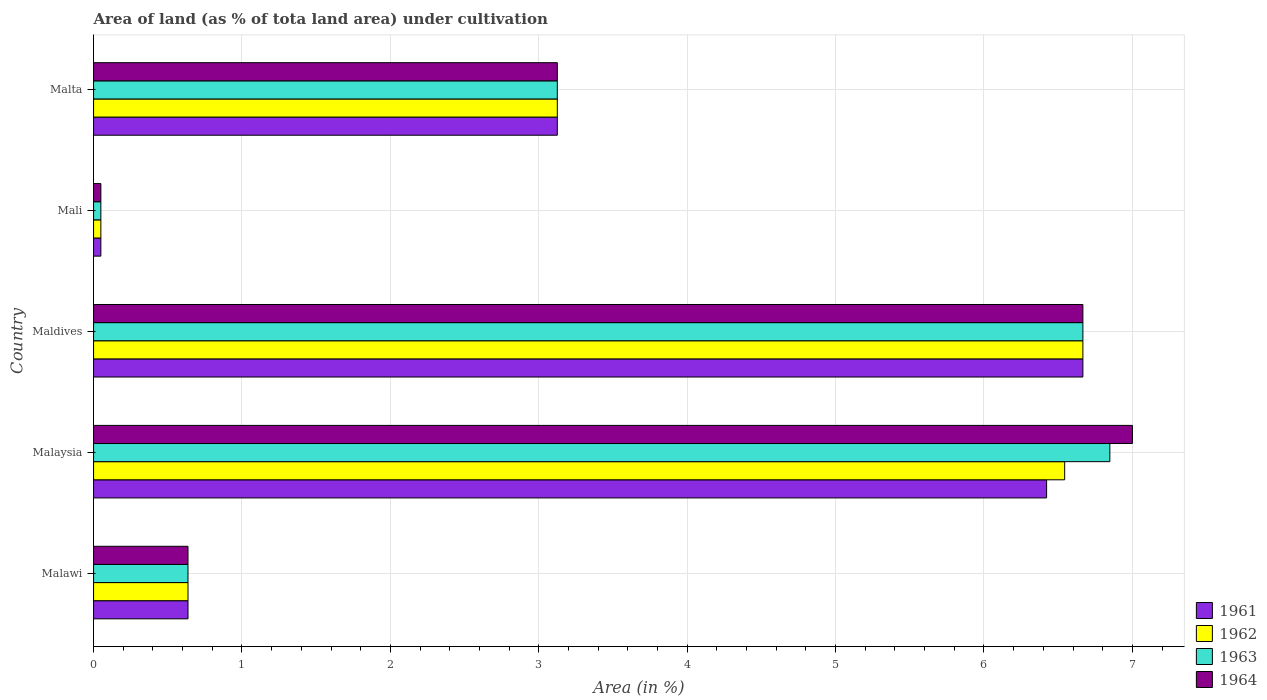How many different coloured bars are there?
Make the answer very short. 4. Are the number of bars on each tick of the Y-axis equal?
Your response must be concise. Yes. What is the label of the 1st group of bars from the top?
Your answer should be compact. Malta. What is the percentage of land under cultivation in 1964 in Malaysia?
Your answer should be very brief. 7. Across all countries, what is the maximum percentage of land under cultivation in 1964?
Give a very brief answer. 7. Across all countries, what is the minimum percentage of land under cultivation in 1963?
Provide a short and direct response. 0.05. In which country was the percentage of land under cultivation in 1962 maximum?
Make the answer very short. Maldives. In which country was the percentage of land under cultivation in 1963 minimum?
Your response must be concise. Mali. What is the total percentage of land under cultivation in 1963 in the graph?
Give a very brief answer. 17.33. What is the difference between the percentage of land under cultivation in 1961 in Mali and that in Malta?
Ensure brevity in your answer.  -3.08. What is the difference between the percentage of land under cultivation in 1961 in Maldives and the percentage of land under cultivation in 1962 in Malawi?
Ensure brevity in your answer.  6.03. What is the average percentage of land under cultivation in 1963 per country?
Your answer should be compact. 3.47. What is the difference between the percentage of land under cultivation in 1964 and percentage of land under cultivation in 1962 in Mali?
Offer a very short reply. 0. What is the ratio of the percentage of land under cultivation in 1963 in Malaysia to that in Maldives?
Keep it short and to the point. 1.03. Is the percentage of land under cultivation in 1961 in Maldives less than that in Malta?
Provide a short and direct response. No. Is the difference between the percentage of land under cultivation in 1964 in Mali and Malta greater than the difference between the percentage of land under cultivation in 1962 in Mali and Malta?
Ensure brevity in your answer.  No. What is the difference between the highest and the second highest percentage of land under cultivation in 1962?
Provide a succinct answer. 0.12. What is the difference between the highest and the lowest percentage of land under cultivation in 1961?
Offer a terse response. 6.62. Is the sum of the percentage of land under cultivation in 1964 in Malawi and Malaysia greater than the maximum percentage of land under cultivation in 1963 across all countries?
Your response must be concise. Yes. Is it the case that in every country, the sum of the percentage of land under cultivation in 1963 and percentage of land under cultivation in 1962 is greater than the sum of percentage of land under cultivation in 1964 and percentage of land under cultivation in 1961?
Provide a short and direct response. No. Is it the case that in every country, the sum of the percentage of land under cultivation in 1964 and percentage of land under cultivation in 1963 is greater than the percentage of land under cultivation in 1962?
Provide a succinct answer. Yes. What is the difference between two consecutive major ticks on the X-axis?
Your answer should be compact. 1. Does the graph contain grids?
Your response must be concise. Yes. Where does the legend appear in the graph?
Offer a very short reply. Bottom right. How many legend labels are there?
Provide a short and direct response. 4. What is the title of the graph?
Provide a short and direct response. Area of land (as % of tota land area) under cultivation. What is the label or title of the X-axis?
Your answer should be very brief. Area (in %). What is the label or title of the Y-axis?
Your answer should be compact. Country. What is the Area (in %) in 1961 in Malawi?
Your answer should be compact. 0.64. What is the Area (in %) in 1962 in Malawi?
Your answer should be very brief. 0.64. What is the Area (in %) of 1963 in Malawi?
Offer a very short reply. 0.64. What is the Area (in %) of 1964 in Malawi?
Ensure brevity in your answer.  0.64. What is the Area (in %) of 1961 in Malaysia?
Keep it short and to the point. 6.42. What is the Area (in %) of 1962 in Malaysia?
Provide a short and direct response. 6.54. What is the Area (in %) in 1963 in Malaysia?
Offer a very short reply. 6.85. What is the Area (in %) of 1964 in Malaysia?
Ensure brevity in your answer.  7. What is the Area (in %) of 1961 in Maldives?
Provide a succinct answer. 6.67. What is the Area (in %) of 1962 in Maldives?
Your response must be concise. 6.67. What is the Area (in %) of 1963 in Maldives?
Provide a succinct answer. 6.67. What is the Area (in %) in 1964 in Maldives?
Offer a terse response. 6.67. What is the Area (in %) in 1961 in Mali?
Offer a very short reply. 0.05. What is the Area (in %) in 1962 in Mali?
Provide a succinct answer. 0.05. What is the Area (in %) in 1963 in Mali?
Ensure brevity in your answer.  0.05. What is the Area (in %) in 1964 in Mali?
Make the answer very short. 0.05. What is the Area (in %) in 1961 in Malta?
Your answer should be compact. 3.12. What is the Area (in %) in 1962 in Malta?
Provide a succinct answer. 3.12. What is the Area (in %) of 1963 in Malta?
Offer a very short reply. 3.12. What is the Area (in %) in 1964 in Malta?
Your response must be concise. 3.12. Across all countries, what is the maximum Area (in %) in 1961?
Make the answer very short. 6.67. Across all countries, what is the maximum Area (in %) in 1962?
Make the answer very short. 6.67. Across all countries, what is the maximum Area (in %) of 1963?
Give a very brief answer. 6.85. Across all countries, what is the maximum Area (in %) of 1964?
Give a very brief answer. 7. Across all countries, what is the minimum Area (in %) in 1961?
Offer a terse response. 0.05. Across all countries, what is the minimum Area (in %) of 1962?
Ensure brevity in your answer.  0.05. Across all countries, what is the minimum Area (in %) of 1963?
Your answer should be very brief. 0.05. Across all countries, what is the minimum Area (in %) in 1964?
Provide a succinct answer. 0.05. What is the total Area (in %) of 1961 in the graph?
Provide a short and direct response. 16.9. What is the total Area (in %) of 1962 in the graph?
Provide a succinct answer. 17.02. What is the total Area (in %) of 1963 in the graph?
Keep it short and to the point. 17.33. What is the total Area (in %) of 1964 in the graph?
Keep it short and to the point. 17.48. What is the difference between the Area (in %) of 1961 in Malawi and that in Malaysia?
Ensure brevity in your answer.  -5.79. What is the difference between the Area (in %) in 1962 in Malawi and that in Malaysia?
Your response must be concise. -5.91. What is the difference between the Area (in %) in 1963 in Malawi and that in Malaysia?
Keep it short and to the point. -6.21. What is the difference between the Area (in %) of 1964 in Malawi and that in Malaysia?
Your response must be concise. -6.36. What is the difference between the Area (in %) in 1961 in Malawi and that in Maldives?
Provide a succinct answer. -6.03. What is the difference between the Area (in %) of 1962 in Malawi and that in Maldives?
Offer a very short reply. -6.03. What is the difference between the Area (in %) in 1963 in Malawi and that in Maldives?
Offer a terse response. -6.03. What is the difference between the Area (in %) of 1964 in Malawi and that in Maldives?
Offer a terse response. -6.03. What is the difference between the Area (in %) in 1961 in Malawi and that in Mali?
Give a very brief answer. 0.59. What is the difference between the Area (in %) of 1962 in Malawi and that in Mali?
Provide a succinct answer. 0.59. What is the difference between the Area (in %) in 1963 in Malawi and that in Mali?
Offer a very short reply. 0.59. What is the difference between the Area (in %) of 1964 in Malawi and that in Mali?
Make the answer very short. 0.59. What is the difference between the Area (in %) of 1961 in Malawi and that in Malta?
Make the answer very short. -2.49. What is the difference between the Area (in %) of 1962 in Malawi and that in Malta?
Provide a succinct answer. -2.49. What is the difference between the Area (in %) in 1963 in Malawi and that in Malta?
Give a very brief answer. -2.49. What is the difference between the Area (in %) in 1964 in Malawi and that in Malta?
Your answer should be compact. -2.49. What is the difference between the Area (in %) of 1961 in Malaysia and that in Maldives?
Provide a succinct answer. -0.24. What is the difference between the Area (in %) in 1962 in Malaysia and that in Maldives?
Give a very brief answer. -0.12. What is the difference between the Area (in %) of 1963 in Malaysia and that in Maldives?
Make the answer very short. 0.18. What is the difference between the Area (in %) in 1964 in Malaysia and that in Maldives?
Provide a succinct answer. 0.33. What is the difference between the Area (in %) in 1961 in Malaysia and that in Mali?
Your response must be concise. 6.37. What is the difference between the Area (in %) in 1962 in Malaysia and that in Mali?
Your response must be concise. 6.49. What is the difference between the Area (in %) of 1963 in Malaysia and that in Mali?
Offer a very short reply. 6.8. What is the difference between the Area (in %) in 1964 in Malaysia and that in Mali?
Offer a very short reply. 6.95. What is the difference between the Area (in %) of 1961 in Malaysia and that in Malta?
Offer a very short reply. 3.3. What is the difference between the Area (in %) in 1962 in Malaysia and that in Malta?
Keep it short and to the point. 3.42. What is the difference between the Area (in %) of 1963 in Malaysia and that in Malta?
Give a very brief answer. 3.72. What is the difference between the Area (in %) of 1964 in Malaysia and that in Malta?
Make the answer very short. 3.88. What is the difference between the Area (in %) of 1961 in Maldives and that in Mali?
Ensure brevity in your answer.  6.62. What is the difference between the Area (in %) in 1962 in Maldives and that in Mali?
Your response must be concise. 6.62. What is the difference between the Area (in %) in 1963 in Maldives and that in Mali?
Give a very brief answer. 6.62. What is the difference between the Area (in %) of 1964 in Maldives and that in Mali?
Ensure brevity in your answer.  6.62. What is the difference between the Area (in %) of 1961 in Maldives and that in Malta?
Your answer should be compact. 3.54. What is the difference between the Area (in %) in 1962 in Maldives and that in Malta?
Offer a terse response. 3.54. What is the difference between the Area (in %) of 1963 in Maldives and that in Malta?
Your response must be concise. 3.54. What is the difference between the Area (in %) in 1964 in Maldives and that in Malta?
Keep it short and to the point. 3.54. What is the difference between the Area (in %) of 1961 in Mali and that in Malta?
Provide a short and direct response. -3.08. What is the difference between the Area (in %) of 1962 in Mali and that in Malta?
Offer a terse response. -3.08. What is the difference between the Area (in %) of 1963 in Mali and that in Malta?
Keep it short and to the point. -3.08. What is the difference between the Area (in %) in 1964 in Mali and that in Malta?
Keep it short and to the point. -3.08. What is the difference between the Area (in %) in 1961 in Malawi and the Area (in %) in 1962 in Malaysia?
Give a very brief answer. -5.91. What is the difference between the Area (in %) in 1961 in Malawi and the Area (in %) in 1963 in Malaysia?
Make the answer very short. -6.21. What is the difference between the Area (in %) in 1961 in Malawi and the Area (in %) in 1964 in Malaysia?
Offer a very short reply. -6.36. What is the difference between the Area (in %) of 1962 in Malawi and the Area (in %) of 1963 in Malaysia?
Ensure brevity in your answer.  -6.21. What is the difference between the Area (in %) of 1962 in Malawi and the Area (in %) of 1964 in Malaysia?
Ensure brevity in your answer.  -6.36. What is the difference between the Area (in %) in 1963 in Malawi and the Area (in %) in 1964 in Malaysia?
Keep it short and to the point. -6.36. What is the difference between the Area (in %) in 1961 in Malawi and the Area (in %) in 1962 in Maldives?
Provide a short and direct response. -6.03. What is the difference between the Area (in %) of 1961 in Malawi and the Area (in %) of 1963 in Maldives?
Provide a short and direct response. -6.03. What is the difference between the Area (in %) of 1961 in Malawi and the Area (in %) of 1964 in Maldives?
Make the answer very short. -6.03. What is the difference between the Area (in %) in 1962 in Malawi and the Area (in %) in 1963 in Maldives?
Give a very brief answer. -6.03. What is the difference between the Area (in %) of 1962 in Malawi and the Area (in %) of 1964 in Maldives?
Keep it short and to the point. -6.03. What is the difference between the Area (in %) of 1963 in Malawi and the Area (in %) of 1964 in Maldives?
Make the answer very short. -6.03. What is the difference between the Area (in %) in 1961 in Malawi and the Area (in %) in 1962 in Mali?
Your response must be concise. 0.59. What is the difference between the Area (in %) in 1961 in Malawi and the Area (in %) in 1963 in Mali?
Offer a very short reply. 0.59. What is the difference between the Area (in %) in 1961 in Malawi and the Area (in %) in 1964 in Mali?
Offer a terse response. 0.59. What is the difference between the Area (in %) in 1962 in Malawi and the Area (in %) in 1963 in Mali?
Offer a terse response. 0.59. What is the difference between the Area (in %) in 1962 in Malawi and the Area (in %) in 1964 in Mali?
Provide a succinct answer. 0.59. What is the difference between the Area (in %) of 1963 in Malawi and the Area (in %) of 1964 in Mali?
Provide a succinct answer. 0.59. What is the difference between the Area (in %) in 1961 in Malawi and the Area (in %) in 1962 in Malta?
Offer a terse response. -2.49. What is the difference between the Area (in %) of 1961 in Malawi and the Area (in %) of 1963 in Malta?
Make the answer very short. -2.49. What is the difference between the Area (in %) in 1961 in Malawi and the Area (in %) in 1964 in Malta?
Ensure brevity in your answer.  -2.49. What is the difference between the Area (in %) in 1962 in Malawi and the Area (in %) in 1963 in Malta?
Make the answer very short. -2.49. What is the difference between the Area (in %) in 1962 in Malawi and the Area (in %) in 1964 in Malta?
Provide a succinct answer. -2.49. What is the difference between the Area (in %) in 1963 in Malawi and the Area (in %) in 1964 in Malta?
Offer a terse response. -2.49. What is the difference between the Area (in %) of 1961 in Malaysia and the Area (in %) of 1962 in Maldives?
Provide a short and direct response. -0.24. What is the difference between the Area (in %) of 1961 in Malaysia and the Area (in %) of 1963 in Maldives?
Your answer should be very brief. -0.24. What is the difference between the Area (in %) of 1961 in Malaysia and the Area (in %) of 1964 in Maldives?
Give a very brief answer. -0.24. What is the difference between the Area (in %) in 1962 in Malaysia and the Area (in %) in 1963 in Maldives?
Provide a short and direct response. -0.12. What is the difference between the Area (in %) of 1962 in Malaysia and the Area (in %) of 1964 in Maldives?
Your response must be concise. -0.12. What is the difference between the Area (in %) of 1963 in Malaysia and the Area (in %) of 1964 in Maldives?
Your answer should be compact. 0.18. What is the difference between the Area (in %) of 1961 in Malaysia and the Area (in %) of 1962 in Mali?
Make the answer very short. 6.37. What is the difference between the Area (in %) of 1961 in Malaysia and the Area (in %) of 1963 in Mali?
Keep it short and to the point. 6.37. What is the difference between the Area (in %) of 1961 in Malaysia and the Area (in %) of 1964 in Mali?
Make the answer very short. 6.37. What is the difference between the Area (in %) in 1962 in Malaysia and the Area (in %) in 1963 in Mali?
Ensure brevity in your answer.  6.49. What is the difference between the Area (in %) of 1962 in Malaysia and the Area (in %) of 1964 in Mali?
Provide a short and direct response. 6.49. What is the difference between the Area (in %) in 1963 in Malaysia and the Area (in %) in 1964 in Mali?
Keep it short and to the point. 6.8. What is the difference between the Area (in %) in 1961 in Malaysia and the Area (in %) in 1962 in Malta?
Keep it short and to the point. 3.3. What is the difference between the Area (in %) of 1961 in Malaysia and the Area (in %) of 1963 in Malta?
Give a very brief answer. 3.3. What is the difference between the Area (in %) in 1961 in Malaysia and the Area (in %) in 1964 in Malta?
Give a very brief answer. 3.3. What is the difference between the Area (in %) in 1962 in Malaysia and the Area (in %) in 1963 in Malta?
Your answer should be very brief. 3.42. What is the difference between the Area (in %) in 1962 in Malaysia and the Area (in %) in 1964 in Malta?
Offer a very short reply. 3.42. What is the difference between the Area (in %) of 1963 in Malaysia and the Area (in %) of 1964 in Malta?
Your answer should be compact. 3.72. What is the difference between the Area (in %) in 1961 in Maldives and the Area (in %) in 1962 in Mali?
Make the answer very short. 6.62. What is the difference between the Area (in %) in 1961 in Maldives and the Area (in %) in 1963 in Mali?
Your response must be concise. 6.62. What is the difference between the Area (in %) of 1961 in Maldives and the Area (in %) of 1964 in Mali?
Provide a short and direct response. 6.62. What is the difference between the Area (in %) in 1962 in Maldives and the Area (in %) in 1963 in Mali?
Ensure brevity in your answer.  6.62. What is the difference between the Area (in %) of 1962 in Maldives and the Area (in %) of 1964 in Mali?
Your answer should be compact. 6.62. What is the difference between the Area (in %) of 1963 in Maldives and the Area (in %) of 1964 in Mali?
Offer a very short reply. 6.62. What is the difference between the Area (in %) of 1961 in Maldives and the Area (in %) of 1962 in Malta?
Provide a succinct answer. 3.54. What is the difference between the Area (in %) in 1961 in Maldives and the Area (in %) in 1963 in Malta?
Provide a succinct answer. 3.54. What is the difference between the Area (in %) of 1961 in Maldives and the Area (in %) of 1964 in Malta?
Your response must be concise. 3.54. What is the difference between the Area (in %) in 1962 in Maldives and the Area (in %) in 1963 in Malta?
Make the answer very short. 3.54. What is the difference between the Area (in %) of 1962 in Maldives and the Area (in %) of 1964 in Malta?
Provide a short and direct response. 3.54. What is the difference between the Area (in %) in 1963 in Maldives and the Area (in %) in 1964 in Malta?
Provide a short and direct response. 3.54. What is the difference between the Area (in %) in 1961 in Mali and the Area (in %) in 1962 in Malta?
Ensure brevity in your answer.  -3.08. What is the difference between the Area (in %) in 1961 in Mali and the Area (in %) in 1963 in Malta?
Provide a succinct answer. -3.08. What is the difference between the Area (in %) of 1961 in Mali and the Area (in %) of 1964 in Malta?
Ensure brevity in your answer.  -3.08. What is the difference between the Area (in %) in 1962 in Mali and the Area (in %) in 1963 in Malta?
Give a very brief answer. -3.08. What is the difference between the Area (in %) of 1962 in Mali and the Area (in %) of 1964 in Malta?
Your answer should be very brief. -3.08. What is the difference between the Area (in %) in 1963 in Mali and the Area (in %) in 1964 in Malta?
Your response must be concise. -3.08. What is the average Area (in %) of 1961 per country?
Your response must be concise. 3.38. What is the average Area (in %) in 1962 per country?
Ensure brevity in your answer.  3.4. What is the average Area (in %) of 1963 per country?
Ensure brevity in your answer.  3.47. What is the average Area (in %) in 1964 per country?
Offer a terse response. 3.5. What is the difference between the Area (in %) of 1961 and Area (in %) of 1962 in Malawi?
Give a very brief answer. 0. What is the difference between the Area (in %) in 1961 and Area (in %) in 1963 in Malawi?
Your answer should be very brief. 0. What is the difference between the Area (in %) in 1961 and Area (in %) in 1964 in Malawi?
Offer a very short reply. 0. What is the difference between the Area (in %) of 1963 and Area (in %) of 1964 in Malawi?
Provide a succinct answer. 0. What is the difference between the Area (in %) in 1961 and Area (in %) in 1962 in Malaysia?
Provide a succinct answer. -0.12. What is the difference between the Area (in %) of 1961 and Area (in %) of 1963 in Malaysia?
Offer a terse response. -0.43. What is the difference between the Area (in %) in 1961 and Area (in %) in 1964 in Malaysia?
Make the answer very short. -0.58. What is the difference between the Area (in %) in 1962 and Area (in %) in 1963 in Malaysia?
Your answer should be compact. -0.3. What is the difference between the Area (in %) of 1962 and Area (in %) of 1964 in Malaysia?
Your response must be concise. -0.46. What is the difference between the Area (in %) in 1963 and Area (in %) in 1964 in Malaysia?
Offer a very short reply. -0.15. What is the difference between the Area (in %) of 1961 and Area (in %) of 1962 in Maldives?
Your response must be concise. 0. What is the difference between the Area (in %) in 1962 and Area (in %) in 1963 in Maldives?
Your answer should be very brief. 0. What is the difference between the Area (in %) of 1962 and Area (in %) of 1964 in Maldives?
Your answer should be compact. 0. What is the difference between the Area (in %) in 1961 and Area (in %) in 1963 in Mali?
Make the answer very short. 0. What is the difference between the Area (in %) in 1961 and Area (in %) in 1964 in Mali?
Your response must be concise. 0. What is the difference between the Area (in %) of 1962 and Area (in %) of 1963 in Mali?
Provide a short and direct response. 0. What is the difference between the Area (in %) of 1961 and Area (in %) of 1962 in Malta?
Your answer should be very brief. 0. What is the difference between the Area (in %) in 1961 and Area (in %) in 1964 in Malta?
Offer a very short reply. 0. What is the difference between the Area (in %) in 1962 and Area (in %) in 1964 in Malta?
Your response must be concise. 0. What is the ratio of the Area (in %) of 1961 in Malawi to that in Malaysia?
Ensure brevity in your answer.  0.1. What is the ratio of the Area (in %) in 1962 in Malawi to that in Malaysia?
Your answer should be very brief. 0.1. What is the ratio of the Area (in %) in 1963 in Malawi to that in Malaysia?
Your response must be concise. 0.09. What is the ratio of the Area (in %) in 1964 in Malawi to that in Malaysia?
Give a very brief answer. 0.09. What is the ratio of the Area (in %) of 1961 in Malawi to that in Maldives?
Provide a succinct answer. 0.1. What is the ratio of the Area (in %) of 1962 in Malawi to that in Maldives?
Your answer should be compact. 0.1. What is the ratio of the Area (in %) in 1963 in Malawi to that in Maldives?
Keep it short and to the point. 0.1. What is the ratio of the Area (in %) in 1964 in Malawi to that in Maldives?
Ensure brevity in your answer.  0.1. What is the ratio of the Area (in %) of 1961 in Malawi to that in Mali?
Give a very brief answer. 12.94. What is the ratio of the Area (in %) of 1962 in Malawi to that in Mali?
Keep it short and to the point. 12.94. What is the ratio of the Area (in %) of 1963 in Malawi to that in Mali?
Your answer should be very brief. 12.94. What is the ratio of the Area (in %) in 1964 in Malawi to that in Mali?
Give a very brief answer. 12.94. What is the ratio of the Area (in %) in 1961 in Malawi to that in Malta?
Your answer should be compact. 0.2. What is the ratio of the Area (in %) of 1962 in Malawi to that in Malta?
Offer a very short reply. 0.2. What is the ratio of the Area (in %) in 1963 in Malawi to that in Malta?
Offer a terse response. 0.2. What is the ratio of the Area (in %) in 1964 in Malawi to that in Malta?
Give a very brief answer. 0.2. What is the ratio of the Area (in %) of 1961 in Malaysia to that in Maldives?
Offer a very short reply. 0.96. What is the ratio of the Area (in %) of 1962 in Malaysia to that in Maldives?
Give a very brief answer. 0.98. What is the ratio of the Area (in %) in 1963 in Malaysia to that in Maldives?
Ensure brevity in your answer.  1.03. What is the ratio of the Area (in %) in 1964 in Malaysia to that in Maldives?
Give a very brief answer. 1.05. What is the ratio of the Area (in %) in 1961 in Malaysia to that in Mali?
Give a very brief answer. 130.6. What is the ratio of the Area (in %) of 1962 in Malaysia to that in Mali?
Offer a very short reply. 133.08. What is the ratio of the Area (in %) in 1963 in Malaysia to that in Mali?
Keep it short and to the point. 139.27. What is the ratio of the Area (in %) of 1964 in Malaysia to that in Mali?
Offer a terse response. 142.36. What is the ratio of the Area (in %) of 1961 in Malaysia to that in Malta?
Your response must be concise. 2.06. What is the ratio of the Area (in %) in 1962 in Malaysia to that in Malta?
Your answer should be very brief. 2.09. What is the ratio of the Area (in %) of 1963 in Malaysia to that in Malta?
Give a very brief answer. 2.19. What is the ratio of the Area (in %) in 1964 in Malaysia to that in Malta?
Offer a terse response. 2.24. What is the ratio of the Area (in %) of 1961 in Maldives to that in Mali?
Make the answer very short. 135.58. What is the ratio of the Area (in %) of 1962 in Maldives to that in Mali?
Ensure brevity in your answer.  135.58. What is the ratio of the Area (in %) of 1963 in Maldives to that in Mali?
Your answer should be compact. 135.58. What is the ratio of the Area (in %) of 1964 in Maldives to that in Mali?
Ensure brevity in your answer.  135.58. What is the ratio of the Area (in %) in 1961 in Maldives to that in Malta?
Offer a very short reply. 2.13. What is the ratio of the Area (in %) in 1962 in Maldives to that in Malta?
Offer a terse response. 2.13. What is the ratio of the Area (in %) in 1963 in Maldives to that in Malta?
Keep it short and to the point. 2.13. What is the ratio of the Area (in %) in 1964 in Maldives to that in Malta?
Provide a succinct answer. 2.13. What is the ratio of the Area (in %) of 1961 in Mali to that in Malta?
Your answer should be compact. 0.02. What is the ratio of the Area (in %) in 1962 in Mali to that in Malta?
Your response must be concise. 0.02. What is the ratio of the Area (in %) of 1963 in Mali to that in Malta?
Ensure brevity in your answer.  0.02. What is the ratio of the Area (in %) in 1964 in Mali to that in Malta?
Make the answer very short. 0.02. What is the difference between the highest and the second highest Area (in %) in 1961?
Your response must be concise. 0.24. What is the difference between the highest and the second highest Area (in %) in 1962?
Ensure brevity in your answer.  0.12. What is the difference between the highest and the second highest Area (in %) of 1963?
Provide a short and direct response. 0.18. What is the difference between the highest and the second highest Area (in %) of 1964?
Provide a succinct answer. 0.33. What is the difference between the highest and the lowest Area (in %) of 1961?
Give a very brief answer. 6.62. What is the difference between the highest and the lowest Area (in %) in 1962?
Ensure brevity in your answer.  6.62. What is the difference between the highest and the lowest Area (in %) in 1963?
Offer a terse response. 6.8. What is the difference between the highest and the lowest Area (in %) in 1964?
Your answer should be very brief. 6.95. 